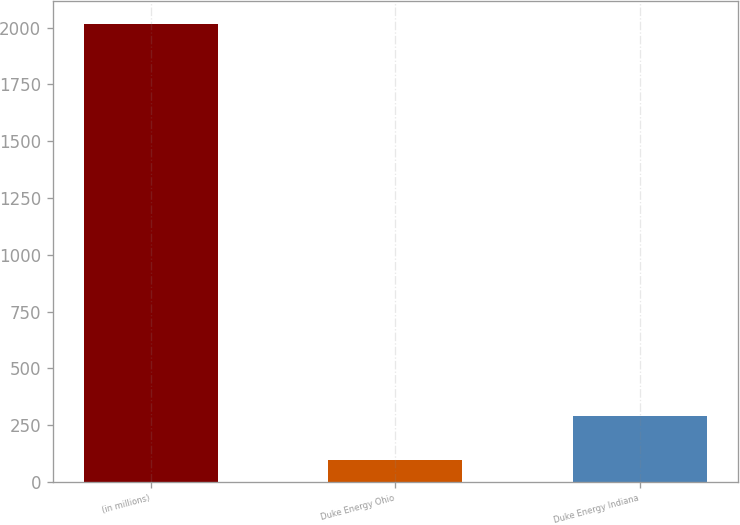Convert chart. <chart><loc_0><loc_0><loc_500><loc_500><bar_chart><fcel>(in millions)<fcel>Duke Energy Ohio<fcel>Duke Energy Indiana<nl><fcel>2016<fcel>97<fcel>288.9<nl></chart> 